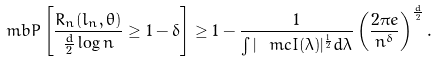<formula> <loc_0><loc_0><loc_500><loc_500>\ m b { P } \left [ \frac { R _ { n } ( l _ { n } , \theta ) } { \frac { d } { 2 } \log n } \geq 1 - \delta \right ] \geq 1 - \frac { 1 } { \int | \ m c { I } ( \lambda ) | ^ { \frac { 1 } { 2 } } d \lambda } \left ( \frac { 2 \pi e } { n ^ { \delta } } \right ) ^ { \frac { d } { 2 } } .</formula> 